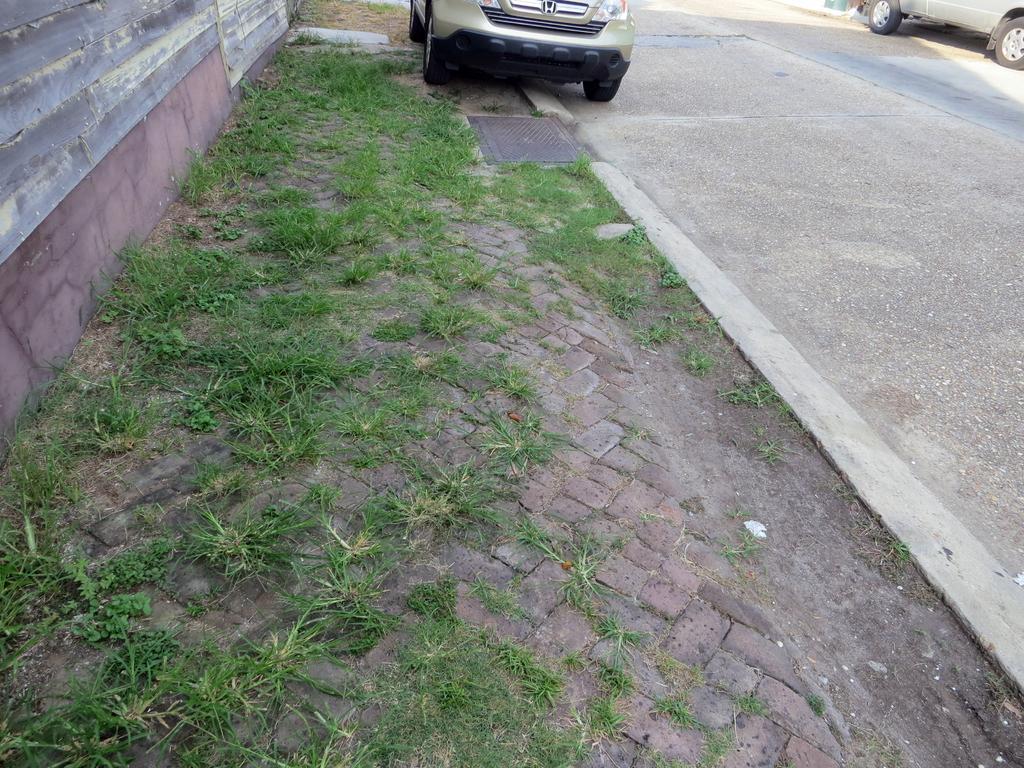Can you describe this image briefly? In this picture I can observe some grass on the land in the middle of the picture. In the top of the picture I can observe two cars on the either sides of the road. On the right side I can observe road. 